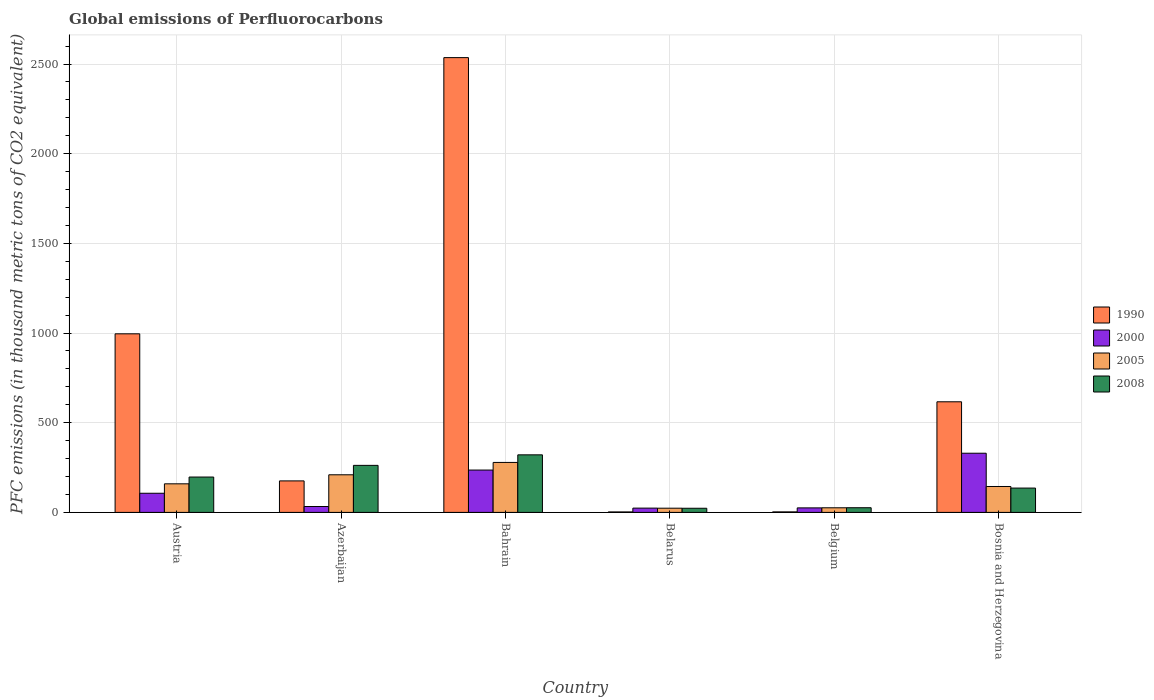How many different coloured bars are there?
Your answer should be compact. 4. Are the number of bars per tick equal to the number of legend labels?
Keep it short and to the point. Yes. What is the label of the 3rd group of bars from the left?
Offer a very short reply. Bahrain. In how many cases, is the number of bars for a given country not equal to the number of legend labels?
Ensure brevity in your answer.  0. What is the global emissions of Perfluorocarbons in 2000 in Bahrain?
Keep it short and to the point. 236.1. Across all countries, what is the maximum global emissions of Perfluorocarbons in 2005?
Your answer should be very brief. 278.6. Across all countries, what is the minimum global emissions of Perfluorocarbons in 2005?
Provide a succinct answer. 23.4. In which country was the global emissions of Perfluorocarbons in 2008 maximum?
Make the answer very short. Bahrain. In which country was the global emissions of Perfluorocarbons in 2000 minimum?
Your answer should be compact. Belarus. What is the total global emissions of Perfluorocarbons in 2008 in the graph?
Keep it short and to the point. 964.9. What is the difference between the global emissions of Perfluorocarbons in 2008 in Austria and that in Bahrain?
Your answer should be very brief. -123.8. What is the difference between the global emissions of Perfluorocarbons in 1990 in Azerbaijan and the global emissions of Perfluorocarbons in 2000 in Bahrain?
Keep it short and to the point. -60.5. What is the average global emissions of Perfluorocarbons in 2005 per country?
Offer a terse response. 140.18. What is the difference between the global emissions of Perfluorocarbons of/in 2000 and global emissions of Perfluorocarbons of/in 1990 in Bosnia and Herzegovina?
Give a very brief answer. -286.8. In how many countries, is the global emissions of Perfluorocarbons in 2008 greater than 1000 thousand metric tons?
Offer a very short reply. 0. What is the ratio of the global emissions of Perfluorocarbons in 2005 in Bahrain to that in Bosnia and Herzegovina?
Offer a terse response. 1.93. Is the global emissions of Perfluorocarbons in 2008 in Austria less than that in Azerbaijan?
Ensure brevity in your answer.  Yes. Is the difference between the global emissions of Perfluorocarbons in 2000 in Austria and Belgium greater than the difference between the global emissions of Perfluorocarbons in 1990 in Austria and Belgium?
Ensure brevity in your answer.  No. What is the difference between the highest and the second highest global emissions of Perfluorocarbons in 2000?
Offer a terse response. 223.2. What is the difference between the highest and the lowest global emissions of Perfluorocarbons in 1990?
Offer a very short reply. 2533.1. Is it the case that in every country, the sum of the global emissions of Perfluorocarbons in 2005 and global emissions of Perfluorocarbons in 2008 is greater than the sum of global emissions of Perfluorocarbons in 2000 and global emissions of Perfluorocarbons in 1990?
Offer a terse response. No. What does the 2nd bar from the right in Belarus represents?
Keep it short and to the point. 2005. How many bars are there?
Your response must be concise. 24. Are all the bars in the graph horizontal?
Offer a very short reply. No. How many countries are there in the graph?
Your answer should be compact. 6. Are the values on the major ticks of Y-axis written in scientific E-notation?
Provide a succinct answer. No. Does the graph contain any zero values?
Make the answer very short. No. Does the graph contain grids?
Make the answer very short. Yes. Where does the legend appear in the graph?
Offer a terse response. Center right. How many legend labels are there?
Provide a short and direct response. 4. What is the title of the graph?
Make the answer very short. Global emissions of Perfluorocarbons. What is the label or title of the Y-axis?
Make the answer very short. PFC emissions (in thousand metric tons of CO2 equivalent). What is the PFC emissions (in thousand metric tons of CO2 equivalent) in 1990 in Austria?
Make the answer very short. 995.7. What is the PFC emissions (in thousand metric tons of CO2 equivalent) of 2000 in Austria?
Offer a terse response. 106.7. What is the PFC emissions (in thousand metric tons of CO2 equivalent) in 2005 in Austria?
Make the answer very short. 159.3. What is the PFC emissions (in thousand metric tons of CO2 equivalent) of 2008 in Austria?
Provide a short and direct response. 197.1. What is the PFC emissions (in thousand metric tons of CO2 equivalent) in 1990 in Azerbaijan?
Offer a terse response. 175.6. What is the PFC emissions (in thousand metric tons of CO2 equivalent) of 2000 in Azerbaijan?
Provide a short and direct response. 32.8. What is the PFC emissions (in thousand metric tons of CO2 equivalent) in 2005 in Azerbaijan?
Your response must be concise. 209.7. What is the PFC emissions (in thousand metric tons of CO2 equivalent) of 2008 in Azerbaijan?
Your answer should be very brief. 262.2. What is the PFC emissions (in thousand metric tons of CO2 equivalent) of 1990 in Bahrain?
Offer a terse response. 2535.7. What is the PFC emissions (in thousand metric tons of CO2 equivalent) in 2000 in Bahrain?
Your answer should be very brief. 236.1. What is the PFC emissions (in thousand metric tons of CO2 equivalent) of 2005 in Bahrain?
Provide a short and direct response. 278.6. What is the PFC emissions (in thousand metric tons of CO2 equivalent) of 2008 in Bahrain?
Provide a short and direct response. 320.9. What is the PFC emissions (in thousand metric tons of CO2 equivalent) of 2000 in Belarus?
Offer a very short reply. 23.9. What is the PFC emissions (in thousand metric tons of CO2 equivalent) in 2005 in Belarus?
Provide a short and direct response. 23.4. What is the PFC emissions (in thousand metric tons of CO2 equivalent) of 2008 in Belarus?
Your answer should be very brief. 23.1. What is the PFC emissions (in thousand metric tons of CO2 equivalent) in 2000 in Belgium?
Your answer should be very brief. 25.2. What is the PFC emissions (in thousand metric tons of CO2 equivalent) in 2005 in Belgium?
Offer a very short reply. 25.7. What is the PFC emissions (in thousand metric tons of CO2 equivalent) of 1990 in Bosnia and Herzegovina?
Provide a short and direct response. 616.7. What is the PFC emissions (in thousand metric tons of CO2 equivalent) of 2000 in Bosnia and Herzegovina?
Your answer should be very brief. 329.9. What is the PFC emissions (in thousand metric tons of CO2 equivalent) in 2005 in Bosnia and Herzegovina?
Provide a succinct answer. 144.4. What is the PFC emissions (in thousand metric tons of CO2 equivalent) of 2008 in Bosnia and Herzegovina?
Offer a terse response. 135.6. Across all countries, what is the maximum PFC emissions (in thousand metric tons of CO2 equivalent) of 1990?
Ensure brevity in your answer.  2535.7. Across all countries, what is the maximum PFC emissions (in thousand metric tons of CO2 equivalent) of 2000?
Your response must be concise. 329.9. Across all countries, what is the maximum PFC emissions (in thousand metric tons of CO2 equivalent) in 2005?
Provide a short and direct response. 278.6. Across all countries, what is the maximum PFC emissions (in thousand metric tons of CO2 equivalent) in 2008?
Your answer should be very brief. 320.9. Across all countries, what is the minimum PFC emissions (in thousand metric tons of CO2 equivalent) of 2000?
Offer a very short reply. 23.9. Across all countries, what is the minimum PFC emissions (in thousand metric tons of CO2 equivalent) in 2005?
Give a very brief answer. 23.4. Across all countries, what is the minimum PFC emissions (in thousand metric tons of CO2 equivalent) of 2008?
Offer a terse response. 23.1. What is the total PFC emissions (in thousand metric tons of CO2 equivalent) in 1990 in the graph?
Provide a succinct answer. 4329.2. What is the total PFC emissions (in thousand metric tons of CO2 equivalent) of 2000 in the graph?
Offer a very short reply. 754.6. What is the total PFC emissions (in thousand metric tons of CO2 equivalent) in 2005 in the graph?
Offer a terse response. 841.1. What is the total PFC emissions (in thousand metric tons of CO2 equivalent) of 2008 in the graph?
Provide a succinct answer. 964.9. What is the difference between the PFC emissions (in thousand metric tons of CO2 equivalent) of 1990 in Austria and that in Azerbaijan?
Make the answer very short. 820.1. What is the difference between the PFC emissions (in thousand metric tons of CO2 equivalent) of 2000 in Austria and that in Azerbaijan?
Offer a terse response. 73.9. What is the difference between the PFC emissions (in thousand metric tons of CO2 equivalent) of 2005 in Austria and that in Azerbaijan?
Your response must be concise. -50.4. What is the difference between the PFC emissions (in thousand metric tons of CO2 equivalent) in 2008 in Austria and that in Azerbaijan?
Provide a succinct answer. -65.1. What is the difference between the PFC emissions (in thousand metric tons of CO2 equivalent) of 1990 in Austria and that in Bahrain?
Keep it short and to the point. -1540. What is the difference between the PFC emissions (in thousand metric tons of CO2 equivalent) of 2000 in Austria and that in Bahrain?
Your response must be concise. -129.4. What is the difference between the PFC emissions (in thousand metric tons of CO2 equivalent) of 2005 in Austria and that in Bahrain?
Your response must be concise. -119.3. What is the difference between the PFC emissions (in thousand metric tons of CO2 equivalent) in 2008 in Austria and that in Bahrain?
Provide a succinct answer. -123.8. What is the difference between the PFC emissions (in thousand metric tons of CO2 equivalent) of 1990 in Austria and that in Belarus?
Your response must be concise. 993.1. What is the difference between the PFC emissions (in thousand metric tons of CO2 equivalent) in 2000 in Austria and that in Belarus?
Provide a short and direct response. 82.8. What is the difference between the PFC emissions (in thousand metric tons of CO2 equivalent) of 2005 in Austria and that in Belarus?
Offer a very short reply. 135.9. What is the difference between the PFC emissions (in thousand metric tons of CO2 equivalent) in 2008 in Austria and that in Belarus?
Your answer should be compact. 174. What is the difference between the PFC emissions (in thousand metric tons of CO2 equivalent) in 1990 in Austria and that in Belgium?
Offer a terse response. 992.8. What is the difference between the PFC emissions (in thousand metric tons of CO2 equivalent) of 2000 in Austria and that in Belgium?
Ensure brevity in your answer.  81.5. What is the difference between the PFC emissions (in thousand metric tons of CO2 equivalent) in 2005 in Austria and that in Belgium?
Give a very brief answer. 133.6. What is the difference between the PFC emissions (in thousand metric tons of CO2 equivalent) in 2008 in Austria and that in Belgium?
Ensure brevity in your answer.  171.1. What is the difference between the PFC emissions (in thousand metric tons of CO2 equivalent) in 1990 in Austria and that in Bosnia and Herzegovina?
Your answer should be compact. 379. What is the difference between the PFC emissions (in thousand metric tons of CO2 equivalent) in 2000 in Austria and that in Bosnia and Herzegovina?
Keep it short and to the point. -223.2. What is the difference between the PFC emissions (in thousand metric tons of CO2 equivalent) of 2008 in Austria and that in Bosnia and Herzegovina?
Your response must be concise. 61.5. What is the difference between the PFC emissions (in thousand metric tons of CO2 equivalent) of 1990 in Azerbaijan and that in Bahrain?
Provide a succinct answer. -2360.1. What is the difference between the PFC emissions (in thousand metric tons of CO2 equivalent) of 2000 in Azerbaijan and that in Bahrain?
Your response must be concise. -203.3. What is the difference between the PFC emissions (in thousand metric tons of CO2 equivalent) in 2005 in Azerbaijan and that in Bahrain?
Keep it short and to the point. -68.9. What is the difference between the PFC emissions (in thousand metric tons of CO2 equivalent) of 2008 in Azerbaijan and that in Bahrain?
Your answer should be compact. -58.7. What is the difference between the PFC emissions (in thousand metric tons of CO2 equivalent) of 1990 in Azerbaijan and that in Belarus?
Make the answer very short. 173. What is the difference between the PFC emissions (in thousand metric tons of CO2 equivalent) of 2005 in Azerbaijan and that in Belarus?
Provide a succinct answer. 186.3. What is the difference between the PFC emissions (in thousand metric tons of CO2 equivalent) of 2008 in Azerbaijan and that in Belarus?
Provide a succinct answer. 239.1. What is the difference between the PFC emissions (in thousand metric tons of CO2 equivalent) in 1990 in Azerbaijan and that in Belgium?
Your response must be concise. 172.7. What is the difference between the PFC emissions (in thousand metric tons of CO2 equivalent) in 2005 in Azerbaijan and that in Belgium?
Your response must be concise. 184. What is the difference between the PFC emissions (in thousand metric tons of CO2 equivalent) of 2008 in Azerbaijan and that in Belgium?
Provide a short and direct response. 236.2. What is the difference between the PFC emissions (in thousand metric tons of CO2 equivalent) in 1990 in Azerbaijan and that in Bosnia and Herzegovina?
Ensure brevity in your answer.  -441.1. What is the difference between the PFC emissions (in thousand metric tons of CO2 equivalent) in 2000 in Azerbaijan and that in Bosnia and Herzegovina?
Your answer should be compact. -297.1. What is the difference between the PFC emissions (in thousand metric tons of CO2 equivalent) of 2005 in Azerbaijan and that in Bosnia and Herzegovina?
Provide a short and direct response. 65.3. What is the difference between the PFC emissions (in thousand metric tons of CO2 equivalent) in 2008 in Azerbaijan and that in Bosnia and Herzegovina?
Make the answer very short. 126.6. What is the difference between the PFC emissions (in thousand metric tons of CO2 equivalent) in 1990 in Bahrain and that in Belarus?
Offer a terse response. 2533.1. What is the difference between the PFC emissions (in thousand metric tons of CO2 equivalent) of 2000 in Bahrain and that in Belarus?
Provide a succinct answer. 212.2. What is the difference between the PFC emissions (in thousand metric tons of CO2 equivalent) in 2005 in Bahrain and that in Belarus?
Your answer should be very brief. 255.2. What is the difference between the PFC emissions (in thousand metric tons of CO2 equivalent) of 2008 in Bahrain and that in Belarus?
Give a very brief answer. 297.8. What is the difference between the PFC emissions (in thousand metric tons of CO2 equivalent) in 1990 in Bahrain and that in Belgium?
Give a very brief answer. 2532.8. What is the difference between the PFC emissions (in thousand metric tons of CO2 equivalent) in 2000 in Bahrain and that in Belgium?
Give a very brief answer. 210.9. What is the difference between the PFC emissions (in thousand metric tons of CO2 equivalent) of 2005 in Bahrain and that in Belgium?
Offer a very short reply. 252.9. What is the difference between the PFC emissions (in thousand metric tons of CO2 equivalent) of 2008 in Bahrain and that in Belgium?
Make the answer very short. 294.9. What is the difference between the PFC emissions (in thousand metric tons of CO2 equivalent) in 1990 in Bahrain and that in Bosnia and Herzegovina?
Your response must be concise. 1919. What is the difference between the PFC emissions (in thousand metric tons of CO2 equivalent) of 2000 in Bahrain and that in Bosnia and Herzegovina?
Provide a succinct answer. -93.8. What is the difference between the PFC emissions (in thousand metric tons of CO2 equivalent) in 2005 in Bahrain and that in Bosnia and Herzegovina?
Your answer should be compact. 134.2. What is the difference between the PFC emissions (in thousand metric tons of CO2 equivalent) in 2008 in Bahrain and that in Bosnia and Herzegovina?
Keep it short and to the point. 185.3. What is the difference between the PFC emissions (in thousand metric tons of CO2 equivalent) in 1990 in Belarus and that in Bosnia and Herzegovina?
Ensure brevity in your answer.  -614.1. What is the difference between the PFC emissions (in thousand metric tons of CO2 equivalent) of 2000 in Belarus and that in Bosnia and Herzegovina?
Provide a short and direct response. -306. What is the difference between the PFC emissions (in thousand metric tons of CO2 equivalent) of 2005 in Belarus and that in Bosnia and Herzegovina?
Give a very brief answer. -121. What is the difference between the PFC emissions (in thousand metric tons of CO2 equivalent) of 2008 in Belarus and that in Bosnia and Herzegovina?
Provide a succinct answer. -112.5. What is the difference between the PFC emissions (in thousand metric tons of CO2 equivalent) of 1990 in Belgium and that in Bosnia and Herzegovina?
Offer a very short reply. -613.8. What is the difference between the PFC emissions (in thousand metric tons of CO2 equivalent) of 2000 in Belgium and that in Bosnia and Herzegovina?
Make the answer very short. -304.7. What is the difference between the PFC emissions (in thousand metric tons of CO2 equivalent) in 2005 in Belgium and that in Bosnia and Herzegovina?
Ensure brevity in your answer.  -118.7. What is the difference between the PFC emissions (in thousand metric tons of CO2 equivalent) in 2008 in Belgium and that in Bosnia and Herzegovina?
Give a very brief answer. -109.6. What is the difference between the PFC emissions (in thousand metric tons of CO2 equivalent) in 1990 in Austria and the PFC emissions (in thousand metric tons of CO2 equivalent) in 2000 in Azerbaijan?
Your response must be concise. 962.9. What is the difference between the PFC emissions (in thousand metric tons of CO2 equivalent) in 1990 in Austria and the PFC emissions (in thousand metric tons of CO2 equivalent) in 2005 in Azerbaijan?
Provide a short and direct response. 786. What is the difference between the PFC emissions (in thousand metric tons of CO2 equivalent) in 1990 in Austria and the PFC emissions (in thousand metric tons of CO2 equivalent) in 2008 in Azerbaijan?
Provide a short and direct response. 733.5. What is the difference between the PFC emissions (in thousand metric tons of CO2 equivalent) of 2000 in Austria and the PFC emissions (in thousand metric tons of CO2 equivalent) of 2005 in Azerbaijan?
Ensure brevity in your answer.  -103. What is the difference between the PFC emissions (in thousand metric tons of CO2 equivalent) of 2000 in Austria and the PFC emissions (in thousand metric tons of CO2 equivalent) of 2008 in Azerbaijan?
Your response must be concise. -155.5. What is the difference between the PFC emissions (in thousand metric tons of CO2 equivalent) in 2005 in Austria and the PFC emissions (in thousand metric tons of CO2 equivalent) in 2008 in Azerbaijan?
Keep it short and to the point. -102.9. What is the difference between the PFC emissions (in thousand metric tons of CO2 equivalent) in 1990 in Austria and the PFC emissions (in thousand metric tons of CO2 equivalent) in 2000 in Bahrain?
Offer a terse response. 759.6. What is the difference between the PFC emissions (in thousand metric tons of CO2 equivalent) of 1990 in Austria and the PFC emissions (in thousand metric tons of CO2 equivalent) of 2005 in Bahrain?
Offer a terse response. 717.1. What is the difference between the PFC emissions (in thousand metric tons of CO2 equivalent) of 1990 in Austria and the PFC emissions (in thousand metric tons of CO2 equivalent) of 2008 in Bahrain?
Your answer should be very brief. 674.8. What is the difference between the PFC emissions (in thousand metric tons of CO2 equivalent) in 2000 in Austria and the PFC emissions (in thousand metric tons of CO2 equivalent) in 2005 in Bahrain?
Ensure brevity in your answer.  -171.9. What is the difference between the PFC emissions (in thousand metric tons of CO2 equivalent) of 2000 in Austria and the PFC emissions (in thousand metric tons of CO2 equivalent) of 2008 in Bahrain?
Offer a terse response. -214.2. What is the difference between the PFC emissions (in thousand metric tons of CO2 equivalent) in 2005 in Austria and the PFC emissions (in thousand metric tons of CO2 equivalent) in 2008 in Bahrain?
Provide a succinct answer. -161.6. What is the difference between the PFC emissions (in thousand metric tons of CO2 equivalent) of 1990 in Austria and the PFC emissions (in thousand metric tons of CO2 equivalent) of 2000 in Belarus?
Make the answer very short. 971.8. What is the difference between the PFC emissions (in thousand metric tons of CO2 equivalent) of 1990 in Austria and the PFC emissions (in thousand metric tons of CO2 equivalent) of 2005 in Belarus?
Your answer should be very brief. 972.3. What is the difference between the PFC emissions (in thousand metric tons of CO2 equivalent) in 1990 in Austria and the PFC emissions (in thousand metric tons of CO2 equivalent) in 2008 in Belarus?
Give a very brief answer. 972.6. What is the difference between the PFC emissions (in thousand metric tons of CO2 equivalent) in 2000 in Austria and the PFC emissions (in thousand metric tons of CO2 equivalent) in 2005 in Belarus?
Keep it short and to the point. 83.3. What is the difference between the PFC emissions (in thousand metric tons of CO2 equivalent) of 2000 in Austria and the PFC emissions (in thousand metric tons of CO2 equivalent) of 2008 in Belarus?
Provide a succinct answer. 83.6. What is the difference between the PFC emissions (in thousand metric tons of CO2 equivalent) of 2005 in Austria and the PFC emissions (in thousand metric tons of CO2 equivalent) of 2008 in Belarus?
Offer a terse response. 136.2. What is the difference between the PFC emissions (in thousand metric tons of CO2 equivalent) in 1990 in Austria and the PFC emissions (in thousand metric tons of CO2 equivalent) in 2000 in Belgium?
Ensure brevity in your answer.  970.5. What is the difference between the PFC emissions (in thousand metric tons of CO2 equivalent) of 1990 in Austria and the PFC emissions (in thousand metric tons of CO2 equivalent) of 2005 in Belgium?
Provide a short and direct response. 970. What is the difference between the PFC emissions (in thousand metric tons of CO2 equivalent) of 1990 in Austria and the PFC emissions (in thousand metric tons of CO2 equivalent) of 2008 in Belgium?
Offer a very short reply. 969.7. What is the difference between the PFC emissions (in thousand metric tons of CO2 equivalent) of 2000 in Austria and the PFC emissions (in thousand metric tons of CO2 equivalent) of 2005 in Belgium?
Your answer should be compact. 81. What is the difference between the PFC emissions (in thousand metric tons of CO2 equivalent) in 2000 in Austria and the PFC emissions (in thousand metric tons of CO2 equivalent) in 2008 in Belgium?
Offer a terse response. 80.7. What is the difference between the PFC emissions (in thousand metric tons of CO2 equivalent) in 2005 in Austria and the PFC emissions (in thousand metric tons of CO2 equivalent) in 2008 in Belgium?
Your answer should be compact. 133.3. What is the difference between the PFC emissions (in thousand metric tons of CO2 equivalent) of 1990 in Austria and the PFC emissions (in thousand metric tons of CO2 equivalent) of 2000 in Bosnia and Herzegovina?
Your answer should be compact. 665.8. What is the difference between the PFC emissions (in thousand metric tons of CO2 equivalent) in 1990 in Austria and the PFC emissions (in thousand metric tons of CO2 equivalent) in 2005 in Bosnia and Herzegovina?
Your answer should be compact. 851.3. What is the difference between the PFC emissions (in thousand metric tons of CO2 equivalent) of 1990 in Austria and the PFC emissions (in thousand metric tons of CO2 equivalent) of 2008 in Bosnia and Herzegovina?
Your response must be concise. 860.1. What is the difference between the PFC emissions (in thousand metric tons of CO2 equivalent) in 2000 in Austria and the PFC emissions (in thousand metric tons of CO2 equivalent) in 2005 in Bosnia and Herzegovina?
Provide a short and direct response. -37.7. What is the difference between the PFC emissions (in thousand metric tons of CO2 equivalent) in 2000 in Austria and the PFC emissions (in thousand metric tons of CO2 equivalent) in 2008 in Bosnia and Herzegovina?
Offer a terse response. -28.9. What is the difference between the PFC emissions (in thousand metric tons of CO2 equivalent) in 2005 in Austria and the PFC emissions (in thousand metric tons of CO2 equivalent) in 2008 in Bosnia and Herzegovina?
Ensure brevity in your answer.  23.7. What is the difference between the PFC emissions (in thousand metric tons of CO2 equivalent) of 1990 in Azerbaijan and the PFC emissions (in thousand metric tons of CO2 equivalent) of 2000 in Bahrain?
Make the answer very short. -60.5. What is the difference between the PFC emissions (in thousand metric tons of CO2 equivalent) in 1990 in Azerbaijan and the PFC emissions (in thousand metric tons of CO2 equivalent) in 2005 in Bahrain?
Make the answer very short. -103. What is the difference between the PFC emissions (in thousand metric tons of CO2 equivalent) of 1990 in Azerbaijan and the PFC emissions (in thousand metric tons of CO2 equivalent) of 2008 in Bahrain?
Provide a succinct answer. -145.3. What is the difference between the PFC emissions (in thousand metric tons of CO2 equivalent) of 2000 in Azerbaijan and the PFC emissions (in thousand metric tons of CO2 equivalent) of 2005 in Bahrain?
Your answer should be very brief. -245.8. What is the difference between the PFC emissions (in thousand metric tons of CO2 equivalent) in 2000 in Azerbaijan and the PFC emissions (in thousand metric tons of CO2 equivalent) in 2008 in Bahrain?
Your answer should be very brief. -288.1. What is the difference between the PFC emissions (in thousand metric tons of CO2 equivalent) of 2005 in Azerbaijan and the PFC emissions (in thousand metric tons of CO2 equivalent) of 2008 in Bahrain?
Offer a very short reply. -111.2. What is the difference between the PFC emissions (in thousand metric tons of CO2 equivalent) in 1990 in Azerbaijan and the PFC emissions (in thousand metric tons of CO2 equivalent) in 2000 in Belarus?
Your answer should be very brief. 151.7. What is the difference between the PFC emissions (in thousand metric tons of CO2 equivalent) in 1990 in Azerbaijan and the PFC emissions (in thousand metric tons of CO2 equivalent) in 2005 in Belarus?
Offer a terse response. 152.2. What is the difference between the PFC emissions (in thousand metric tons of CO2 equivalent) of 1990 in Azerbaijan and the PFC emissions (in thousand metric tons of CO2 equivalent) of 2008 in Belarus?
Provide a succinct answer. 152.5. What is the difference between the PFC emissions (in thousand metric tons of CO2 equivalent) in 2000 in Azerbaijan and the PFC emissions (in thousand metric tons of CO2 equivalent) in 2008 in Belarus?
Your answer should be compact. 9.7. What is the difference between the PFC emissions (in thousand metric tons of CO2 equivalent) of 2005 in Azerbaijan and the PFC emissions (in thousand metric tons of CO2 equivalent) of 2008 in Belarus?
Your answer should be very brief. 186.6. What is the difference between the PFC emissions (in thousand metric tons of CO2 equivalent) of 1990 in Azerbaijan and the PFC emissions (in thousand metric tons of CO2 equivalent) of 2000 in Belgium?
Your answer should be very brief. 150.4. What is the difference between the PFC emissions (in thousand metric tons of CO2 equivalent) in 1990 in Azerbaijan and the PFC emissions (in thousand metric tons of CO2 equivalent) in 2005 in Belgium?
Offer a very short reply. 149.9. What is the difference between the PFC emissions (in thousand metric tons of CO2 equivalent) in 1990 in Azerbaijan and the PFC emissions (in thousand metric tons of CO2 equivalent) in 2008 in Belgium?
Ensure brevity in your answer.  149.6. What is the difference between the PFC emissions (in thousand metric tons of CO2 equivalent) of 2000 in Azerbaijan and the PFC emissions (in thousand metric tons of CO2 equivalent) of 2008 in Belgium?
Your answer should be very brief. 6.8. What is the difference between the PFC emissions (in thousand metric tons of CO2 equivalent) in 2005 in Azerbaijan and the PFC emissions (in thousand metric tons of CO2 equivalent) in 2008 in Belgium?
Your response must be concise. 183.7. What is the difference between the PFC emissions (in thousand metric tons of CO2 equivalent) of 1990 in Azerbaijan and the PFC emissions (in thousand metric tons of CO2 equivalent) of 2000 in Bosnia and Herzegovina?
Make the answer very short. -154.3. What is the difference between the PFC emissions (in thousand metric tons of CO2 equivalent) in 1990 in Azerbaijan and the PFC emissions (in thousand metric tons of CO2 equivalent) in 2005 in Bosnia and Herzegovina?
Provide a short and direct response. 31.2. What is the difference between the PFC emissions (in thousand metric tons of CO2 equivalent) in 2000 in Azerbaijan and the PFC emissions (in thousand metric tons of CO2 equivalent) in 2005 in Bosnia and Herzegovina?
Offer a terse response. -111.6. What is the difference between the PFC emissions (in thousand metric tons of CO2 equivalent) of 2000 in Azerbaijan and the PFC emissions (in thousand metric tons of CO2 equivalent) of 2008 in Bosnia and Herzegovina?
Give a very brief answer. -102.8. What is the difference between the PFC emissions (in thousand metric tons of CO2 equivalent) of 2005 in Azerbaijan and the PFC emissions (in thousand metric tons of CO2 equivalent) of 2008 in Bosnia and Herzegovina?
Provide a short and direct response. 74.1. What is the difference between the PFC emissions (in thousand metric tons of CO2 equivalent) in 1990 in Bahrain and the PFC emissions (in thousand metric tons of CO2 equivalent) in 2000 in Belarus?
Make the answer very short. 2511.8. What is the difference between the PFC emissions (in thousand metric tons of CO2 equivalent) in 1990 in Bahrain and the PFC emissions (in thousand metric tons of CO2 equivalent) in 2005 in Belarus?
Make the answer very short. 2512.3. What is the difference between the PFC emissions (in thousand metric tons of CO2 equivalent) of 1990 in Bahrain and the PFC emissions (in thousand metric tons of CO2 equivalent) of 2008 in Belarus?
Provide a succinct answer. 2512.6. What is the difference between the PFC emissions (in thousand metric tons of CO2 equivalent) in 2000 in Bahrain and the PFC emissions (in thousand metric tons of CO2 equivalent) in 2005 in Belarus?
Make the answer very short. 212.7. What is the difference between the PFC emissions (in thousand metric tons of CO2 equivalent) of 2000 in Bahrain and the PFC emissions (in thousand metric tons of CO2 equivalent) of 2008 in Belarus?
Give a very brief answer. 213. What is the difference between the PFC emissions (in thousand metric tons of CO2 equivalent) of 2005 in Bahrain and the PFC emissions (in thousand metric tons of CO2 equivalent) of 2008 in Belarus?
Your answer should be compact. 255.5. What is the difference between the PFC emissions (in thousand metric tons of CO2 equivalent) of 1990 in Bahrain and the PFC emissions (in thousand metric tons of CO2 equivalent) of 2000 in Belgium?
Your response must be concise. 2510.5. What is the difference between the PFC emissions (in thousand metric tons of CO2 equivalent) of 1990 in Bahrain and the PFC emissions (in thousand metric tons of CO2 equivalent) of 2005 in Belgium?
Your answer should be very brief. 2510. What is the difference between the PFC emissions (in thousand metric tons of CO2 equivalent) of 1990 in Bahrain and the PFC emissions (in thousand metric tons of CO2 equivalent) of 2008 in Belgium?
Ensure brevity in your answer.  2509.7. What is the difference between the PFC emissions (in thousand metric tons of CO2 equivalent) of 2000 in Bahrain and the PFC emissions (in thousand metric tons of CO2 equivalent) of 2005 in Belgium?
Give a very brief answer. 210.4. What is the difference between the PFC emissions (in thousand metric tons of CO2 equivalent) in 2000 in Bahrain and the PFC emissions (in thousand metric tons of CO2 equivalent) in 2008 in Belgium?
Make the answer very short. 210.1. What is the difference between the PFC emissions (in thousand metric tons of CO2 equivalent) of 2005 in Bahrain and the PFC emissions (in thousand metric tons of CO2 equivalent) of 2008 in Belgium?
Ensure brevity in your answer.  252.6. What is the difference between the PFC emissions (in thousand metric tons of CO2 equivalent) in 1990 in Bahrain and the PFC emissions (in thousand metric tons of CO2 equivalent) in 2000 in Bosnia and Herzegovina?
Provide a short and direct response. 2205.8. What is the difference between the PFC emissions (in thousand metric tons of CO2 equivalent) in 1990 in Bahrain and the PFC emissions (in thousand metric tons of CO2 equivalent) in 2005 in Bosnia and Herzegovina?
Your answer should be compact. 2391.3. What is the difference between the PFC emissions (in thousand metric tons of CO2 equivalent) in 1990 in Bahrain and the PFC emissions (in thousand metric tons of CO2 equivalent) in 2008 in Bosnia and Herzegovina?
Keep it short and to the point. 2400.1. What is the difference between the PFC emissions (in thousand metric tons of CO2 equivalent) of 2000 in Bahrain and the PFC emissions (in thousand metric tons of CO2 equivalent) of 2005 in Bosnia and Herzegovina?
Provide a short and direct response. 91.7. What is the difference between the PFC emissions (in thousand metric tons of CO2 equivalent) of 2000 in Bahrain and the PFC emissions (in thousand metric tons of CO2 equivalent) of 2008 in Bosnia and Herzegovina?
Offer a terse response. 100.5. What is the difference between the PFC emissions (in thousand metric tons of CO2 equivalent) of 2005 in Bahrain and the PFC emissions (in thousand metric tons of CO2 equivalent) of 2008 in Bosnia and Herzegovina?
Provide a short and direct response. 143. What is the difference between the PFC emissions (in thousand metric tons of CO2 equivalent) of 1990 in Belarus and the PFC emissions (in thousand metric tons of CO2 equivalent) of 2000 in Belgium?
Your answer should be compact. -22.6. What is the difference between the PFC emissions (in thousand metric tons of CO2 equivalent) in 1990 in Belarus and the PFC emissions (in thousand metric tons of CO2 equivalent) in 2005 in Belgium?
Your answer should be very brief. -23.1. What is the difference between the PFC emissions (in thousand metric tons of CO2 equivalent) in 1990 in Belarus and the PFC emissions (in thousand metric tons of CO2 equivalent) in 2008 in Belgium?
Keep it short and to the point. -23.4. What is the difference between the PFC emissions (in thousand metric tons of CO2 equivalent) of 2005 in Belarus and the PFC emissions (in thousand metric tons of CO2 equivalent) of 2008 in Belgium?
Offer a very short reply. -2.6. What is the difference between the PFC emissions (in thousand metric tons of CO2 equivalent) in 1990 in Belarus and the PFC emissions (in thousand metric tons of CO2 equivalent) in 2000 in Bosnia and Herzegovina?
Ensure brevity in your answer.  -327.3. What is the difference between the PFC emissions (in thousand metric tons of CO2 equivalent) in 1990 in Belarus and the PFC emissions (in thousand metric tons of CO2 equivalent) in 2005 in Bosnia and Herzegovina?
Keep it short and to the point. -141.8. What is the difference between the PFC emissions (in thousand metric tons of CO2 equivalent) of 1990 in Belarus and the PFC emissions (in thousand metric tons of CO2 equivalent) of 2008 in Bosnia and Herzegovina?
Your response must be concise. -133. What is the difference between the PFC emissions (in thousand metric tons of CO2 equivalent) of 2000 in Belarus and the PFC emissions (in thousand metric tons of CO2 equivalent) of 2005 in Bosnia and Herzegovina?
Make the answer very short. -120.5. What is the difference between the PFC emissions (in thousand metric tons of CO2 equivalent) of 2000 in Belarus and the PFC emissions (in thousand metric tons of CO2 equivalent) of 2008 in Bosnia and Herzegovina?
Offer a very short reply. -111.7. What is the difference between the PFC emissions (in thousand metric tons of CO2 equivalent) of 2005 in Belarus and the PFC emissions (in thousand metric tons of CO2 equivalent) of 2008 in Bosnia and Herzegovina?
Make the answer very short. -112.2. What is the difference between the PFC emissions (in thousand metric tons of CO2 equivalent) of 1990 in Belgium and the PFC emissions (in thousand metric tons of CO2 equivalent) of 2000 in Bosnia and Herzegovina?
Make the answer very short. -327. What is the difference between the PFC emissions (in thousand metric tons of CO2 equivalent) in 1990 in Belgium and the PFC emissions (in thousand metric tons of CO2 equivalent) in 2005 in Bosnia and Herzegovina?
Make the answer very short. -141.5. What is the difference between the PFC emissions (in thousand metric tons of CO2 equivalent) of 1990 in Belgium and the PFC emissions (in thousand metric tons of CO2 equivalent) of 2008 in Bosnia and Herzegovina?
Give a very brief answer. -132.7. What is the difference between the PFC emissions (in thousand metric tons of CO2 equivalent) in 2000 in Belgium and the PFC emissions (in thousand metric tons of CO2 equivalent) in 2005 in Bosnia and Herzegovina?
Your answer should be very brief. -119.2. What is the difference between the PFC emissions (in thousand metric tons of CO2 equivalent) in 2000 in Belgium and the PFC emissions (in thousand metric tons of CO2 equivalent) in 2008 in Bosnia and Herzegovina?
Offer a terse response. -110.4. What is the difference between the PFC emissions (in thousand metric tons of CO2 equivalent) in 2005 in Belgium and the PFC emissions (in thousand metric tons of CO2 equivalent) in 2008 in Bosnia and Herzegovina?
Offer a terse response. -109.9. What is the average PFC emissions (in thousand metric tons of CO2 equivalent) in 1990 per country?
Offer a terse response. 721.53. What is the average PFC emissions (in thousand metric tons of CO2 equivalent) in 2000 per country?
Ensure brevity in your answer.  125.77. What is the average PFC emissions (in thousand metric tons of CO2 equivalent) in 2005 per country?
Make the answer very short. 140.18. What is the average PFC emissions (in thousand metric tons of CO2 equivalent) of 2008 per country?
Provide a succinct answer. 160.82. What is the difference between the PFC emissions (in thousand metric tons of CO2 equivalent) in 1990 and PFC emissions (in thousand metric tons of CO2 equivalent) in 2000 in Austria?
Keep it short and to the point. 889. What is the difference between the PFC emissions (in thousand metric tons of CO2 equivalent) in 1990 and PFC emissions (in thousand metric tons of CO2 equivalent) in 2005 in Austria?
Give a very brief answer. 836.4. What is the difference between the PFC emissions (in thousand metric tons of CO2 equivalent) in 1990 and PFC emissions (in thousand metric tons of CO2 equivalent) in 2008 in Austria?
Your response must be concise. 798.6. What is the difference between the PFC emissions (in thousand metric tons of CO2 equivalent) in 2000 and PFC emissions (in thousand metric tons of CO2 equivalent) in 2005 in Austria?
Keep it short and to the point. -52.6. What is the difference between the PFC emissions (in thousand metric tons of CO2 equivalent) of 2000 and PFC emissions (in thousand metric tons of CO2 equivalent) of 2008 in Austria?
Provide a succinct answer. -90.4. What is the difference between the PFC emissions (in thousand metric tons of CO2 equivalent) in 2005 and PFC emissions (in thousand metric tons of CO2 equivalent) in 2008 in Austria?
Your answer should be very brief. -37.8. What is the difference between the PFC emissions (in thousand metric tons of CO2 equivalent) in 1990 and PFC emissions (in thousand metric tons of CO2 equivalent) in 2000 in Azerbaijan?
Provide a succinct answer. 142.8. What is the difference between the PFC emissions (in thousand metric tons of CO2 equivalent) in 1990 and PFC emissions (in thousand metric tons of CO2 equivalent) in 2005 in Azerbaijan?
Make the answer very short. -34.1. What is the difference between the PFC emissions (in thousand metric tons of CO2 equivalent) in 1990 and PFC emissions (in thousand metric tons of CO2 equivalent) in 2008 in Azerbaijan?
Your answer should be compact. -86.6. What is the difference between the PFC emissions (in thousand metric tons of CO2 equivalent) of 2000 and PFC emissions (in thousand metric tons of CO2 equivalent) of 2005 in Azerbaijan?
Your response must be concise. -176.9. What is the difference between the PFC emissions (in thousand metric tons of CO2 equivalent) in 2000 and PFC emissions (in thousand metric tons of CO2 equivalent) in 2008 in Azerbaijan?
Offer a very short reply. -229.4. What is the difference between the PFC emissions (in thousand metric tons of CO2 equivalent) of 2005 and PFC emissions (in thousand metric tons of CO2 equivalent) of 2008 in Azerbaijan?
Offer a terse response. -52.5. What is the difference between the PFC emissions (in thousand metric tons of CO2 equivalent) of 1990 and PFC emissions (in thousand metric tons of CO2 equivalent) of 2000 in Bahrain?
Your answer should be compact. 2299.6. What is the difference between the PFC emissions (in thousand metric tons of CO2 equivalent) in 1990 and PFC emissions (in thousand metric tons of CO2 equivalent) in 2005 in Bahrain?
Your answer should be very brief. 2257.1. What is the difference between the PFC emissions (in thousand metric tons of CO2 equivalent) in 1990 and PFC emissions (in thousand metric tons of CO2 equivalent) in 2008 in Bahrain?
Offer a very short reply. 2214.8. What is the difference between the PFC emissions (in thousand metric tons of CO2 equivalent) in 2000 and PFC emissions (in thousand metric tons of CO2 equivalent) in 2005 in Bahrain?
Your answer should be very brief. -42.5. What is the difference between the PFC emissions (in thousand metric tons of CO2 equivalent) in 2000 and PFC emissions (in thousand metric tons of CO2 equivalent) in 2008 in Bahrain?
Ensure brevity in your answer.  -84.8. What is the difference between the PFC emissions (in thousand metric tons of CO2 equivalent) in 2005 and PFC emissions (in thousand metric tons of CO2 equivalent) in 2008 in Bahrain?
Your answer should be very brief. -42.3. What is the difference between the PFC emissions (in thousand metric tons of CO2 equivalent) in 1990 and PFC emissions (in thousand metric tons of CO2 equivalent) in 2000 in Belarus?
Keep it short and to the point. -21.3. What is the difference between the PFC emissions (in thousand metric tons of CO2 equivalent) in 1990 and PFC emissions (in thousand metric tons of CO2 equivalent) in 2005 in Belarus?
Ensure brevity in your answer.  -20.8. What is the difference between the PFC emissions (in thousand metric tons of CO2 equivalent) of 1990 and PFC emissions (in thousand metric tons of CO2 equivalent) of 2008 in Belarus?
Offer a very short reply. -20.5. What is the difference between the PFC emissions (in thousand metric tons of CO2 equivalent) of 2000 and PFC emissions (in thousand metric tons of CO2 equivalent) of 2005 in Belarus?
Give a very brief answer. 0.5. What is the difference between the PFC emissions (in thousand metric tons of CO2 equivalent) of 2000 and PFC emissions (in thousand metric tons of CO2 equivalent) of 2008 in Belarus?
Offer a very short reply. 0.8. What is the difference between the PFC emissions (in thousand metric tons of CO2 equivalent) of 1990 and PFC emissions (in thousand metric tons of CO2 equivalent) of 2000 in Belgium?
Offer a very short reply. -22.3. What is the difference between the PFC emissions (in thousand metric tons of CO2 equivalent) in 1990 and PFC emissions (in thousand metric tons of CO2 equivalent) in 2005 in Belgium?
Your response must be concise. -22.8. What is the difference between the PFC emissions (in thousand metric tons of CO2 equivalent) of 1990 and PFC emissions (in thousand metric tons of CO2 equivalent) of 2008 in Belgium?
Ensure brevity in your answer.  -23.1. What is the difference between the PFC emissions (in thousand metric tons of CO2 equivalent) in 2000 and PFC emissions (in thousand metric tons of CO2 equivalent) in 2005 in Belgium?
Ensure brevity in your answer.  -0.5. What is the difference between the PFC emissions (in thousand metric tons of CO2 equivalent) of 2005 and PFC emissions (in thousand metric tons of CO2 equivalent) of 2008 in Belgium?
Provide a succinct answer. -0.3. What is the difference between the PFC emissions (in thousand metric tons of CO2 equivalent) of 1990 and PFC emissions (in thousand metric tons of CO2 equivalent) of 2000 in Bosnia and Herzegovina?
Ensure brevity in your answer.  286.8. What is the difference between the PFC emissions (in thousand metric tons of CO2 equivalent) of 1990 and PFC emissions (in thousand metric tons of CO2 equivalent) of 2005 in Bosnia and Herzegovina?
Offer a very short reply. 472.3. What is the difference between the PFC emissions (in thousand metric tons of CO2 equivalent) in 1990 and PFC emissions (in thousand metric tons of CO2 equivalent) in 2008 in Bosnia and Herzegovina?
Your response must be concise. 481.1. What is the difference between the PFC emissions (in thousand metric tons of CO2 equivalent) in 2000 and PFC emissions (in thousand metric tons of CO2 equivalent) in 2005 in Bosnia and Herzegovina?
Make the answer very short. 185.5. What is the difference between the PFC emissions (in thousand metric tons of CO2 equivalent) of 2000 and PFC emissions (in thousand metric tons of CO2 equivalent) of 2008 in Bosnia and Herzegovina?
Keep it short and to the point. 194.3. What is the difference between the PFC emissions (in thousand metric tons of CO2 equivalent) of 2005 and PFC emissions (in thousand metric tons of CO2 equivalent) of 2008 in Bosnia and Herzegovina?
Ensure brevity in your answer.  8.8. What is the ratio of the PFC emissions (in thousand metric tons of CO2 equivalent) of 1990 in Austria to that in Azerbaijan?
Your answer should be very brief. 5.67. What is the ratio of the PFC emissions (in thousand metric tons of CO2 equivalent) in 2000 in Austria to that in Azerbaijan?
Offer a very short reply. 3.25. What is the ratio of the PFC emissions (in thousand metric tons of CO2 equivalent) in 2005 in Austria to that in Azerbaijan?
Offer a very short reply. 0.76. What is the ratio of the PFC emissions (in thousand metric tons of CO2 equivalent) of 2008 in Austria to that in Azerbaijan?
Make the answer very short. 0.75. What is the ratio of the PFC emissions (in thousand metric tons of CO2 equivalent) in 1990 in Austria to that in Bahrain?
Offer a very short reply. 0.39. What is the ratio of the PFC emissions (in thousand metric tons of CO2 equivalent) in 2000 in Austria to that in Bahrain?
Make the answer very short. 0.45. What is the ratio of the PFC emissions (in thousand metric tons of CO2 equivalent) of 2005 in Austria to that in Bahrain?
Provide a short and direct response. 0.57. What is the ratio of the PFC emissions (in thousand metric tons of CO2 equivalent) of 2008 in Austria to that in Bahrain?
Keep it short and to the point. 0.61. What is the ratio of the PFC emissions (in thousand metric tons of CO2 equivalent) of 1990 in Austria to that in Belarus?
Your answer should be very brief. 382.96. What is the ratio of the PFC emissions (in thousand metric tons of CO2 equivalent) of 2000 in Austria to that in Belarus?
Offer a terse response. 4.46. What is the ratio of the PFC emissions (in thousand metric tons of CO2 equivalent) in 2005 in Austria to that in Belarus?
Give a very brief answer. 6.81. What is the ratio of the PFC emissions (in thousand metric tons of CO2 equivalent) of 2008 in Austria to that in Belarus?
Your response must be concise. 8.53. What is the ratio of the PFC emissions (in thousand metric tons of CO2 equivalent) of 1990 in Austria to that in Belgium?
Ensure brevity in your answer.  343.34. What is the ratio of the PFC emissions (in thousand metric tons of CO2 equivalent) of 2000 in Austria to that in Belgium?
Offer a very short reply. 4.23. What is the ratio of the PFC emissions (in thousand metric tons of CO2 equivalent) in 2005 in Austria to that in Belgium?
Keep it short and to the point. 6.2. What is the ratio of the PFC emissions (in thousand metric tons of CO2 equivalent) of 2008 in Austria to that in Belgium?
Your answer should be compact. 7.58. What is the ratio of the PFC emissions (in thousand metric tons of CO2 equivalent) of 1990 in Austria to that in Bosnia and Herzegovina?
Offer a terse response. 1.61. What is the ratio of the PFC emissions (in thousand metric tons of CO2 equivalent) in 2000 in Austria to that in Bosnia and Herzegovina?
Your response must be concise. 0.32. What is the ratio of the PFC emissions (in thousand metric tons of CO2 equivalent) of 2005 in Austria to that in Bosnia and Herzegovina?
Ensure brevity in your answer.  1.1. What is the ratio of the PFC emissions (in thousand metric tons of CO2 equivalent) in 2008 in Austria to that in Bosnia and Herzegovina?
Provide a succinct answer. 1.45. What is the ratio of the PFC emissions (in thousand metric tons of CO2 equivalent) in 1990 in Azerbaijan to that in Bahrain?
Ensure brevity in your answer.  0.07. What is the ratio of the PFC emissions (in thousand metric tons of CO2 equivalent) in 2000 in Azerbaijan to that in Bahrain?
Give a very brief answer. 0.14. What is the ratio of the PFC emissions (in thousand metric tons of CO2 equivalent) of 2005 in Azerbaijan to that in Bahrain?
Provide a short and direct response. 0.75. What is the ratio of the PFC emissions (in thousand metric tons of CO2 equivalent) of 2008 in Azerbaijan to that in Bahrain?
Offer a terse response. 0.82. What is the ratio of the PFC emissions (in thousand metric tons of CO2 equivalent) in 1990 in Azerbaijan to that in Belarus?
Your answer should be compact. 67.54. What is the ratio of the PFC emissions (in thousand metric tons of CO2 equivalent) in 2000 in Azerbaijan to that in Belarus?
Your answer should be very brief. 1.37. What is the ratio of the PFC emissions (in thousand metric tons of CO2 equivalent) of 2005 in Azerbaijan to that in Belarus?
Make the answer very short. 8.96. What is the ratio of the PFC emissions (in thousand metric tons of CO2 equivalent) in 2008 in Azerbaijan to that in Belarus?
Give a very brief answer. 11.35. What is the ratio of the PFC emissions (in thousand metric tons of CO2 equivalent) of 1990 in Azerbaijan to that in Belgium?
Provide a short and direct response. 60.55. What is the ratio of the PFC emissions (in thousand metric tons of CO2 equivalent) of 2000 in Azerbaijan to that in Belgium?
Give a very brief answer. 1.3. What is the ratio of the PFC emissions (in thousand metric tons of CO2 equivalent) of 2005 in Azerbaijan to that in Belgium?
Provide a succinct answer. 8.16. What is the ratio of the PFC emissions (in thousand metric tons of CO2 equivalent) in 2008 in Azerbaijan to that in Belgium?
Keep it short and to the point. 10.08. What is the ratio of the PFC emissions (in thousand metric tons of CO2 equivalent) in 1990 in Azerbaijan to that in Bosnia and Herzegovina?
Keep it short and to the point. 0.28. What is the ratio of the PFC emissions (in thousand metric tons of CO2 equivalent) in 2000 in Azerbaijan to that in Bosnia and Herzegovina?
Give a very brief answer. 0.1. What is the ratio of the PFC emissions (in thousand metric tons of CO2 equivalent) of 2005 in Azerbaijan to that in Bosnia and Herzegovina?
Offer a very short reply. 1.45. What is the ratio of the PFC emissions (in thousand metric tons of CO2 equivalent) of 2008 in Azerbaijan to that in Bosnia and Herzegovina?
Make the answer very short. 1.93. What is the ratio of the PFC emissions (in thousand metric tons of CO2 equivalent) in 1990 in Bahrain to that in Belarus?
Give a very brief answer. 975.27. What is the ratio of the PFC emissions (in thousand metric tons of CO2 equivalent) in 2000 in Bahrain to that in Belarus?
Make the answer very short. 9.88. What is the ratio of the PFC emissions (in thousand metric tons of CO2 equivalent) in 2005 in Bahrain to that in Belarus?
Provide a short and direct response. 11.91. What is the ratio of the PFC emissions (in thousand metric tons of CO2 equivalent) in 2008 in Bahrain to that in Belarus?
Ensure brevity in your answer.  13.89. What is the ratio of the PFC emissions (in thousand metric tons of CO2 equivalent) in 1990 in Bahrain to that in Belgium?
Offer a very short reply. 874.38. What is the ratio of the PFC emissions (in thousand metric tons of CO2 equivalent) in 2000 in Bahrain to that in Belgium?
Your answer should be very brief. 9.37. What is the ratio of the PFC emissions (in thousand metric tons of CO2 equivalent) in 2005 in Bahrain to that in Belgium?
Offer a terse response. 10.84. What is the ratio of the PFC emissions (in thousand metric tons of CO2 equivalent) of 2008 in Bahrain to that in Belgium?
Provide a short and direct response. 12.34. What is the ratio of the PFC emissions (in thousand metric tons of CO2 equivalent) of 1990 in Bahrain to that in Bosnia and Herzegovina?
Your response must be concise. 4.11. What is the ratio of the PFC emissions (in thousand metric tons of CO2 equivalent) in 2000 in Bahrain to that in Bosnia and Herzegovina?
Your answer should be compact. 0.72. What is the ratio of the PFC emissions (in thousand metric tons of CO2 equivalent) in 2005 in Bahrain to that in Bosnia and Herzegovina?
Provide a short and direct response. 1.93. What is the ratio of the PFC emissions (in thousand metric tons of CO2 equivalent) in 2008 in Bahrain to that in Bosnia and Herzegovina?
Keep it short and to the point. 2.37. What is the ratio of the PFC emissions (in thousand metric tons of CO2 equivalent) in 1990 in Belarus to that in Belgium?
Give a very brief answer. 0.9. What is the ratio of the PFC emissions (in thousand metric tons of CO2 equivalent) of 2000 in Belarus to that in Belgium?
Offer a terse response. 0.95. What is the ratio of the PFC emissions (in thousand metric tons of CO2 equivalent) in 2005 in Belarus to that in Belgium?
Your answer should be compact. 0.91. What is the ratio of the PFC emissions (in thousand metric tons of CO2 equivalent) of 2008 in Belarus to that in Belgium?
Offer a terse response. 0.89. What is the ratio of the PFC emissions (in thousand metric tons of CO2 equivalent) of 1990 in Belarus to that in Bosnia and Herzegovina?
Provide a succinct answer. 0. What is the ratio of the PFC emissions (in thousand metric tons of CO2 equivalent) in 2000 in Belarus to that in Bosnia and Herzegovina?
Offer a terse response. 0.07. What is the ratio of the PFC emissions (in thousand metric tons of CO2 equivalent) in 2005 in Belarus to that in Bosnia and Herzegovina?
Your answer should be very brief. 0.16. What is the ratio of the PFC emissions (in thousand metric tons of CO2 equivalent) in 2008 in Belarus to that in Bosnia and Herzegovina?
Offer a very short reply. 0.17. What is the ratio of the PFC emissions (in thousand metric tons of CO2 equivalent) in 1990 in Belgium to that in Bosnia and Herzegovina?
Provide a succinct answer. 0. What is the ratio of the PFC emissions (in thousand metric tons of CO2 equivalent) in 2000 in Belgium to that in Bosnia and Herzegovina?
Offer a very short reply. 0.08. What is the ratio of the PFC emissions (in thousand metric tons of CO2 equivalent) in 2005 in Belgium to that in Bosnia and Herzegovina?
Make the answer very short. 0.18. What is the ratio of the PFC emissions (in thousand metric tons of CO2 equivalent) in 2008 in Belgium to that in Bosnia and Herzegovina?
Make the answer very short. 0.19. What is the difference between the highest and the second highest PFC emissions (in thousand metric tons of CO2 equivalent) in 1990?
Offer a very short reply. 1540. What is the difference between the highest and the second highest PFC emissions (in thousand metric tons of CO2 equivalent) of 2000?
Offer a very short reply. 93.8. What is the difference between the highest and the second highest PFC emissions (in thousand metric tons of CO2 equivalent) of 2005?
Provide a succinct answer. 68.9. What is the difference between the highest and the second highest PFC emissions (in thousand metric tons of CO2 equivalent) of 2008?
Your answer should be compact. 58.7. What is the difference between the highest and the lowest PFC emissions (in thousand metric tons of CO2 equivalent) in 1990?
Provide a succinct answer. 2533.1. What is the difference between the highest and the lowest PFC emissions (in thousand metric tons of CO2 equivalent) of 2000?
Your answer should be compact. 306. What is the difference between the highest and the lowest PFC emissions (in thousand metric tons of CO2 equivalent) of 2005?
Your answer should be compact. 255.2. What is the difference between the highest and the lowest PFC emissions (in thousand metric tons of CO2 equivalent) in 2008?
Keep it short and to the point. 297.8. 